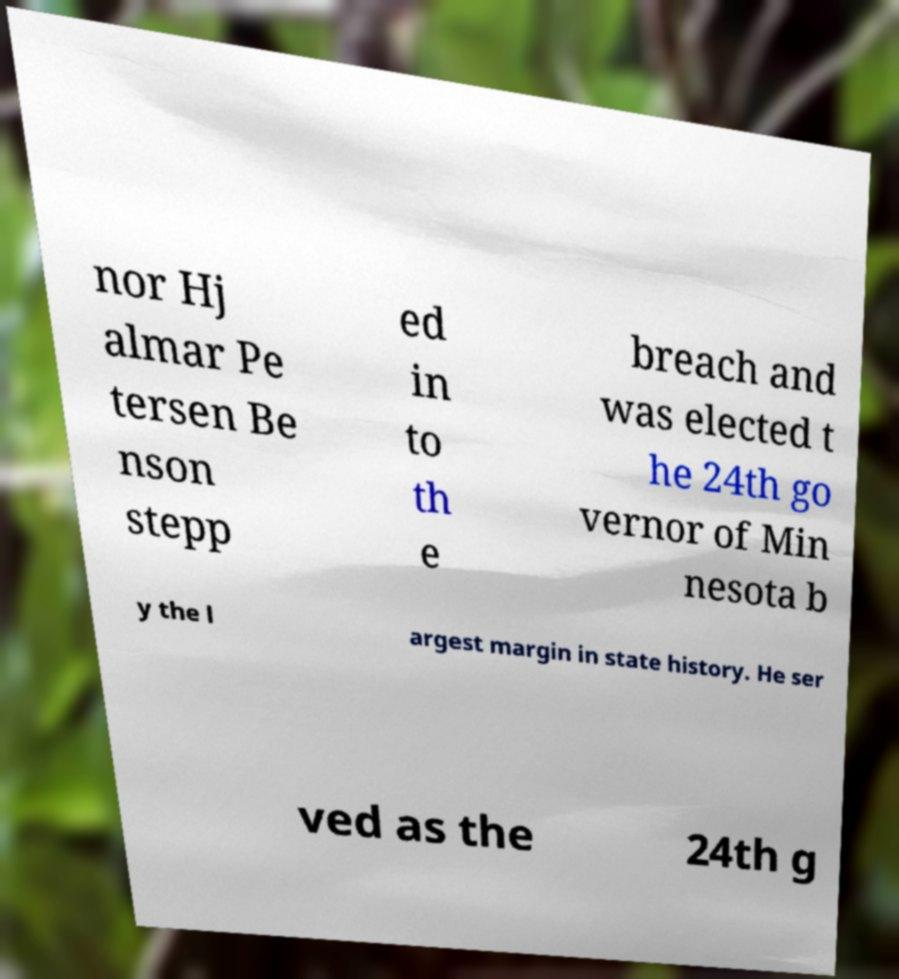For documentation purposes, I need the text within this image transcribed. Could you provide that? nor Hj almar Pe tersen Be nson stepp ed in to th e breach and was elected t he 24th go vernor of Min nesota b y the l argest margin in state history. He ser ved as the 24th g 